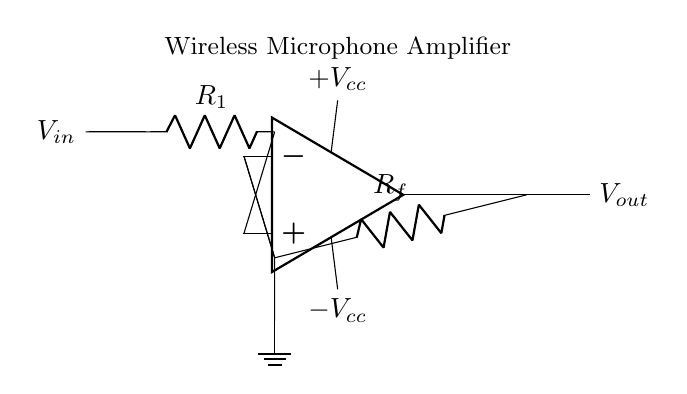What is the input voltage of the circuit? The input voltage is denoted as V_in in the circuit diagram, which indicates the voltage applied to the non-inverting terminal of the operational amplifier.
Answer: V_in What are the resistor values in the circuit? The circuit includes two resistors: R_1, which is connected to the input voltage, and R_f, which is connected in the feedback loop. Their specific values are not given, but their presence is indicated in the diagram.
Answer: R_1, R_f How many power supplies does the operational amplifier have? The operational amplifier has two power supplies, labeled as +V_cc and -V_cc in the circuit. These provide the necessary voltage levels for the amplifier to function appropriately.
Answer: Two What is the output voltage represented in the circuit? The output voltage is represented as V_out and is connected to the output terminal of the operational amplifier. This voltage is the amplified signal that is sent to the next stage of the circuit or the microphone.
Answer: V_out What is the role of the feedback resistor (R_f)? The feedback resistor R_f is used to set the gain of the operational amplifier circuit, influencing how much the input signal is amplified. This is a critical design aspect for achieving the desired performance in signal amplification applications.
Answer: Gain control What type of circuit is shown here? This is an operational amplifier circuit used for signal amplification, specifically designed for applications like wireless microphones where high fidelity and signal strength are crucial.
Answer: Operational amplifier circuit What does the ground connection indicate in this circuit? The ground connection indicates the reference point for the circuit voltages; it is essential for establishing a common voltage level against which other voltages (like input and output) are measured.
Answer: Reference point 